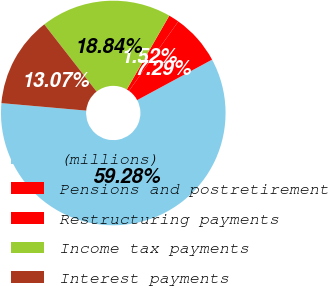<chart> <loc_0><loc_0><loc_500><loc_500><pie_chart><fcel>(millions)<fcel>Pensions and postretirement<fcel>Restructuring payments<fcel>Income tax payments<fcel>Interest payments<nl><fcel>59.28%<fcel>7.29%<fcel>1.52%<fcel>18.84%<fcel>13.07%<nl></chart> 